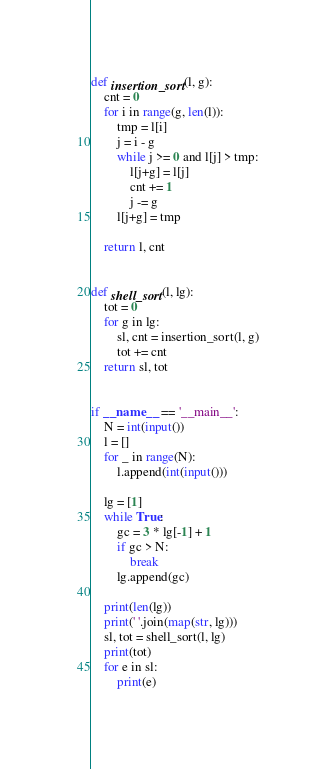<code> <loc_0><loc_0><loc_500><loc_500><_Python_>def insertion_sort(l, g):
    cnt = 0
    for i in range(g, len(l)):
        tmp = l[i]
        j = i - g
        while j >= 0 and l[j] > tmp:
            l[j+g] = l[j]
            cnt += 1
            j -= g
        l[j+g] = tmp

    return l, cnt


def shell_sort(l, lg):
    tot = 0
    for g in lg:
        sl, cnt = insertion_sort(l, g)
        tot += cnt
    return sl, tot


if __name__ == '__main__':
    N = int(input())
    l = []
    for _ in range(N):
        l.append(int(input()))

    lg = [1]
    while True:
        gc = 3 * lg[-1] + 1
        if gc > N:
            break
        lg.append(gc)

    print(len(lg))
    print(' '.join(map(str, lg)))
    sl, tot = shell_sort(l, lg)
    print(tot)
    for e in sl:
        print(e)

</code> 